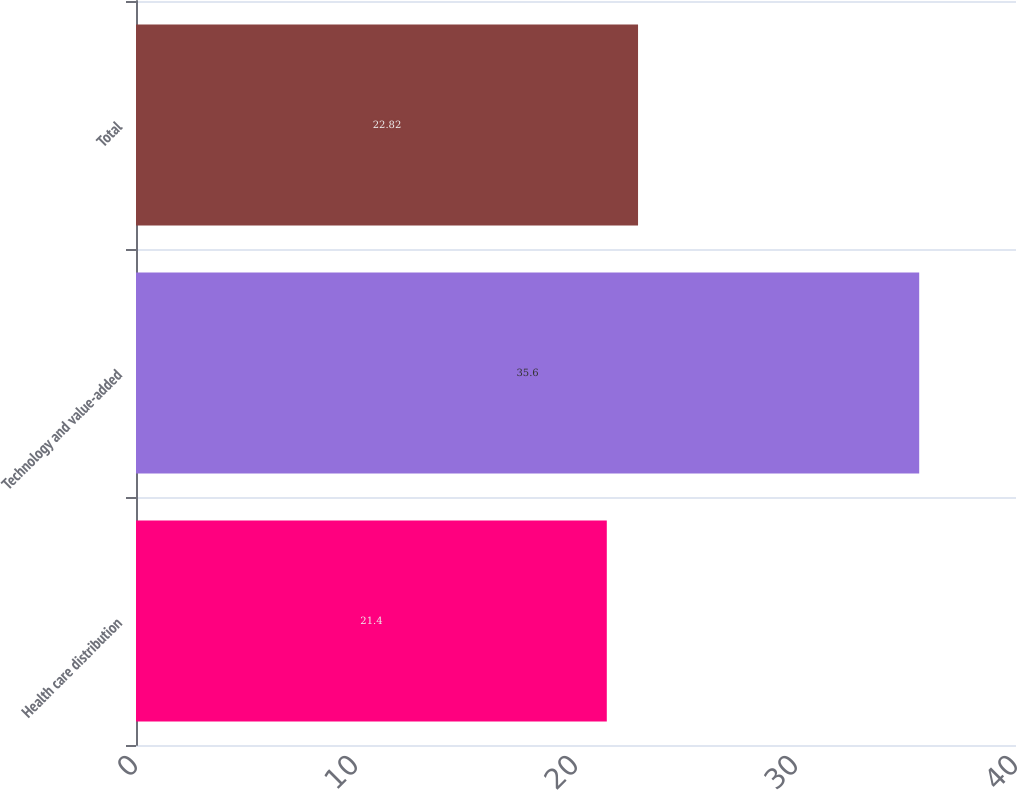<chart> <loc_0><loc_0><loc_500><loc_500><bar_chart><fcel>Health care distribution<fcel>Technology and value-added<fcel>Total<nl><fcel>21.4<fcel>35.6<fcel>22.82<nl></chart> 